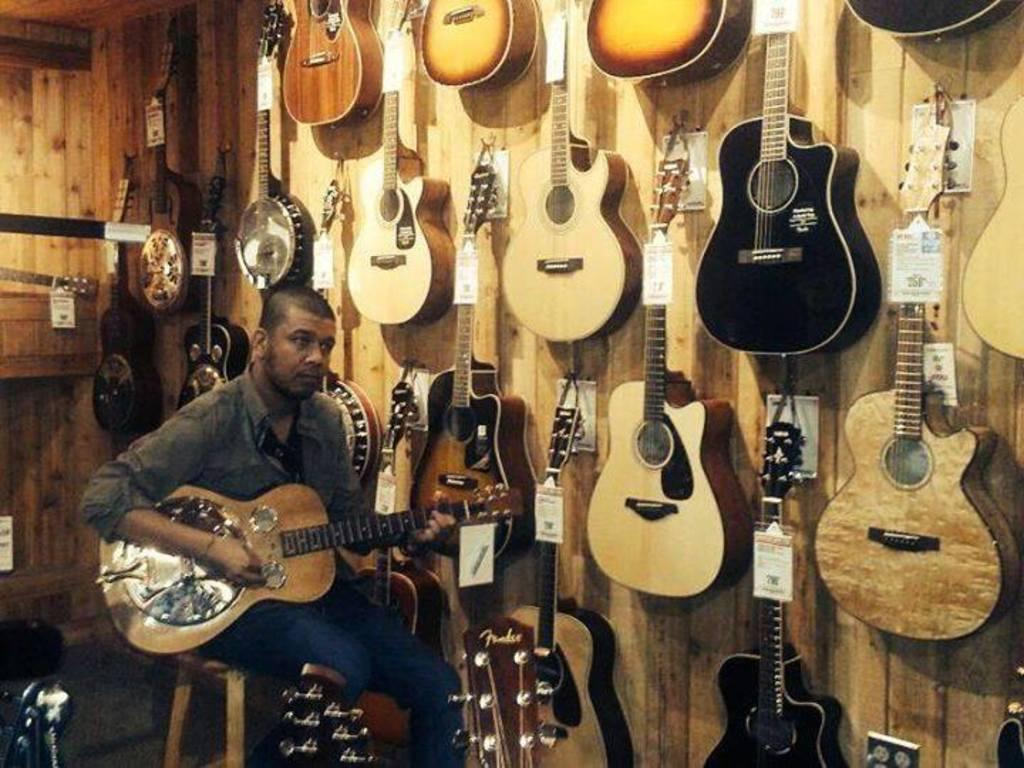What is the person in the image doing? The person is sitting on a chair and playing a guitar. Can you describe the background of the image? There is a group of guitars on a wooden wall in the background of the image. What type of advice can be heard from the frog in the image? There is no frog present in the image, so it is not possible to hear any advice from a frog. 